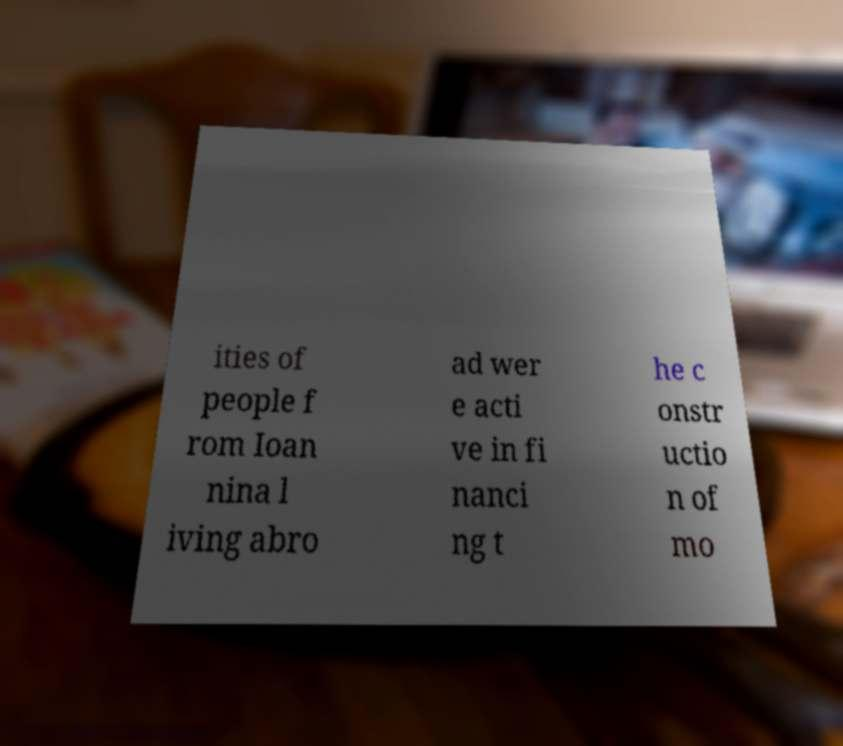I need the written content from this picture converted into text. Can you do that? ities of people f rom Ioan nina l iving abro ad wer e acti ve in fi nanci ng t he c onstr uctio n of mo 